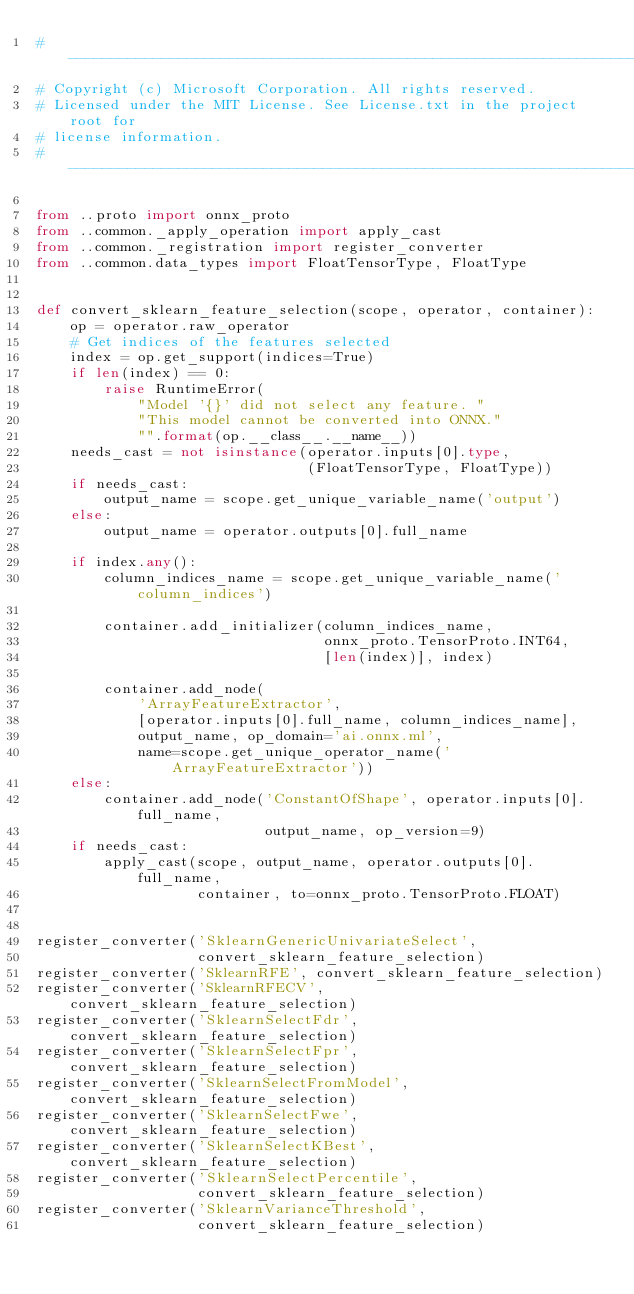<code> <loc_0><loc_0><loc_500><loc_500><_Python_># -------------------------------------------------------------------------
# Copyright (c) Microsoft Corporation. All rights reserved.
# Licensed under the MIT License. See License.txt in the project root for
# license information.
# --------------------------------------------------------------------------

from ..proto import onnx_proto
from ..common._apply_operation import apply_cast
from ..common._registration import register_converter
from ..common.data_types import FloatTensorType, FloatType


def convert_sklearn_feature_selection(scope, operator, container):
    op = operator.raw_operator
    # Get indices of the features selected
    index = op.get_support(indices=True)
    if len(index) == 0:
        raise RuntimeError(
            "Model '{}' did not select any feature. "
            "This model cannot be converted into ONNX."
            "".format(op.__class__.__name__))
    needs_cast = not isinstance(operator.inputs[0].type,
                                (FloatTensorType, FloatType))
    if needs_cast:
        output_name = scope.get_unique_variable_name('output')
    else:
        output_name = operator.outputs[0].full_name

    if index.any():
        column_indices_name = scope.get_unique_variable_name('column_indices')

        container.add_initializer(column_indices_name,
                                  onnx_proto.TensorProto.INT64,
                                  [len(index)], index)

        container.add_node(
            'ArrayFeatureExtractor',
            [operator.inputs[0].full_name, column_indices_name],
            output_name, op_domain='ai.onnx.ml',
            name=scope.get_unique_operator_name('ArrayFeatureExtractor'))
    else:
        container.add_node('ConstantOfShape', operator.inputs[0].full_name,
                           output_name, op_version=9)
    if needs_cast:
        apply_cast(scope, output_name, operator.outputs[0].full_name,
                   container, to=onnx_proto.TensorProto.FLOAT)


register_converter('SklearnGenericUnivariateSelect',
                   convert_sklearn_feature_selection)
register_converter('SklearnRFE', convert_sklearn_feature_selection)
register_converter('SklearnRFECV', convert_sklearn_feature_selection)
register_converter('SklearnSelectFdr', convert_sklearn_feature_selection)
register_converter('SklearnSelectFpr', convert_sklearn_feature_selection)
register_converter('SklearnSelectFromModel', convert_sklearn_feature_selection)
register_converter('SklearnSelectFwe', convert_sklearn_feature_selection)
register_converter('SklearnSelectKBest', convert_sklearn_feature_selection)
register_converter('SklearnSelectPercentile',
                   convert_sklearn_feature_selection)
register_converter('SklearnVarianceThreshold',
                   convert_sklearn_feature_selection)
</code> 